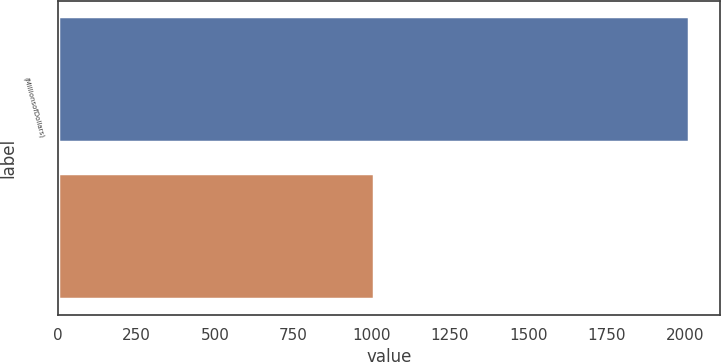<chart> <loc_0><loc_0><loc_500><loc_500><bar_chart><fcel>(MillionsofDollars)<fcel>Unnamed: 1<nl><fcel>2012<fcel>1006.5<nl></chart> 